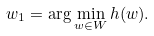Convert formula to latex. <formula><loc_0><loc_0><loc_500><loc_500>w _ { 1 } = \arg \min _ { w \in W } h ( w ) .</formula> 